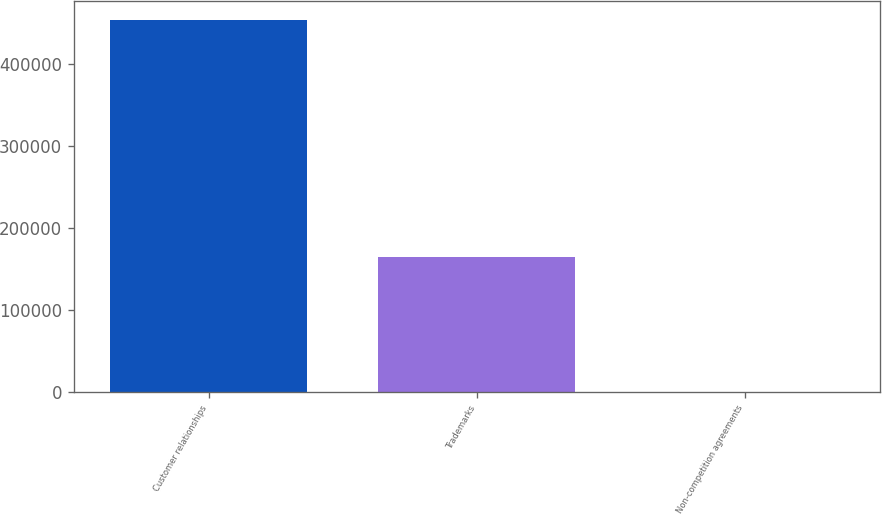Convert chart to OTSL. <chart><loc_0><loc_0><loc_500><loc_500><bar_chart><fcel>Customer relationships<fcel>Trademarks<fcel>Non-competition agreements<nl><fcel>453616<fcel>164262<fcel>632<nl></chart> 